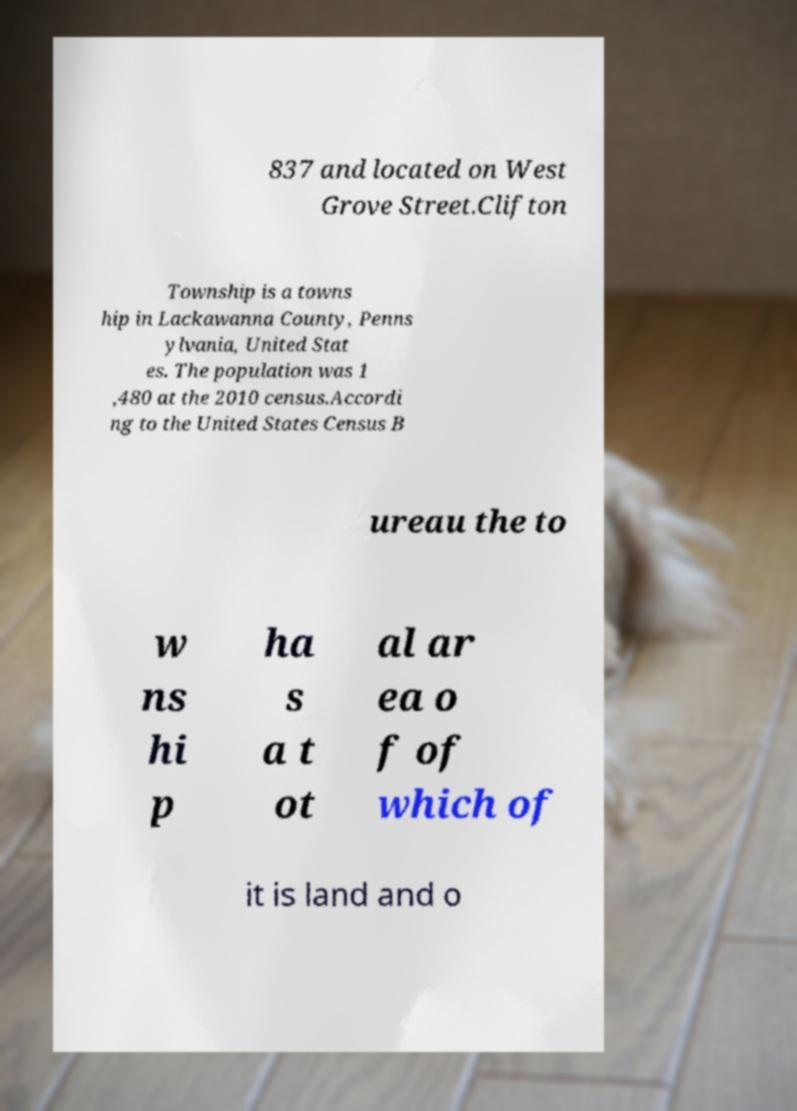What messages or text are displayed in this image? I need them in a readable, typed format. 837 and located on West Grove Street.Clifton Township is a towns hip in Lackawanna County, Penns ylvania, United Stat es. The population was 1 ,480 at the 2010 census.Accordi ng to the United States Census B ureau the to w ns hi p ha s a t ot al ar ea o f of which of it is land and o 